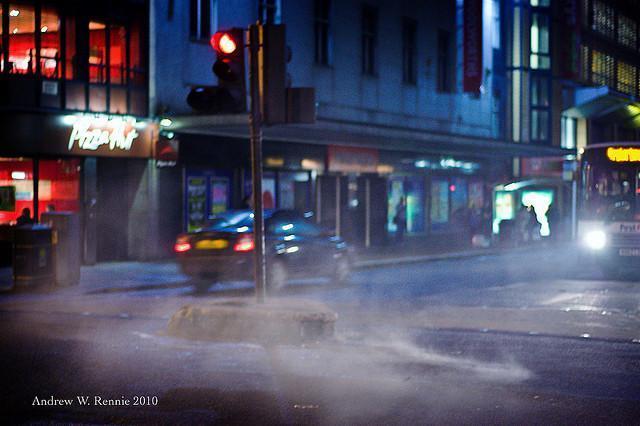How many traffic lights are there?
Give a very brief answer. 2. How many prongs does the fork have?
Give a very brief answer. 0. 